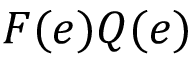Convert formula to latex. <formula><loc_0><loc_0><loc_500><loc_500>F ( e ) Q ( e )</formula> 